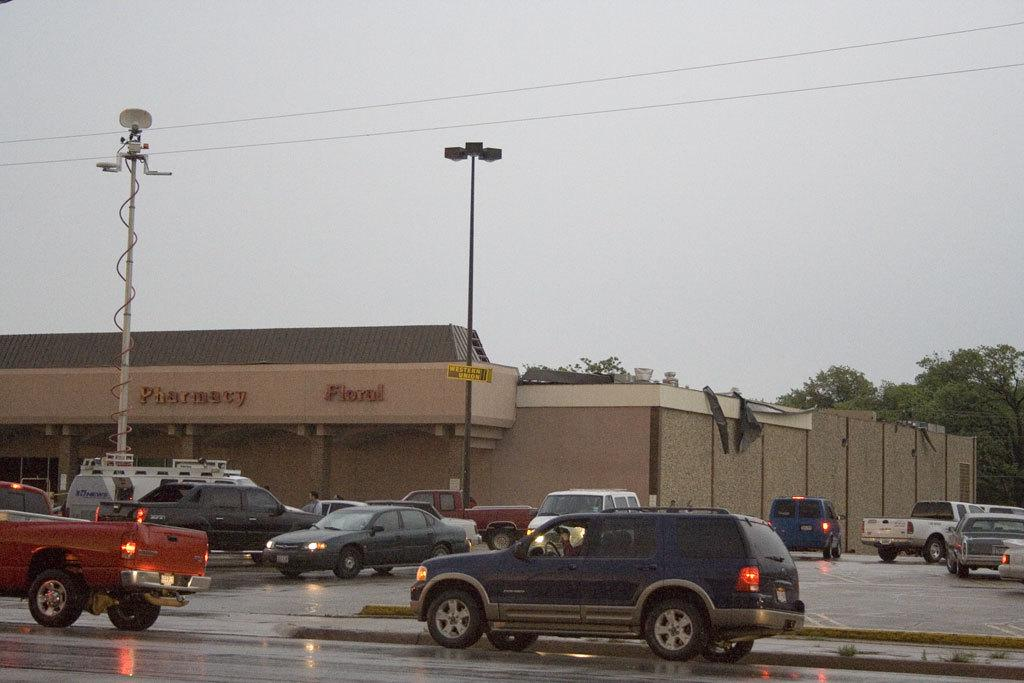What can be seen on the road in the image? There are vehicles on the road in the image. What is attached to the pole in the image? There is a street light with a pole in the image. What else can be seen in the image besides the vehicles and street light? Wires, a building with a roof, and trees are present in the image. What is visible in the sky in the image? The sky is visible in the image and appears cloudy. How many bulbs are present in the image? There is no mention of bulbs in the image; it features vehicles, a street light, wires, a building, trees, and a cloudy sky. What type of house is visible in the image? There is no house present in the image; it features a building with a roof, but it is not a residential house. 